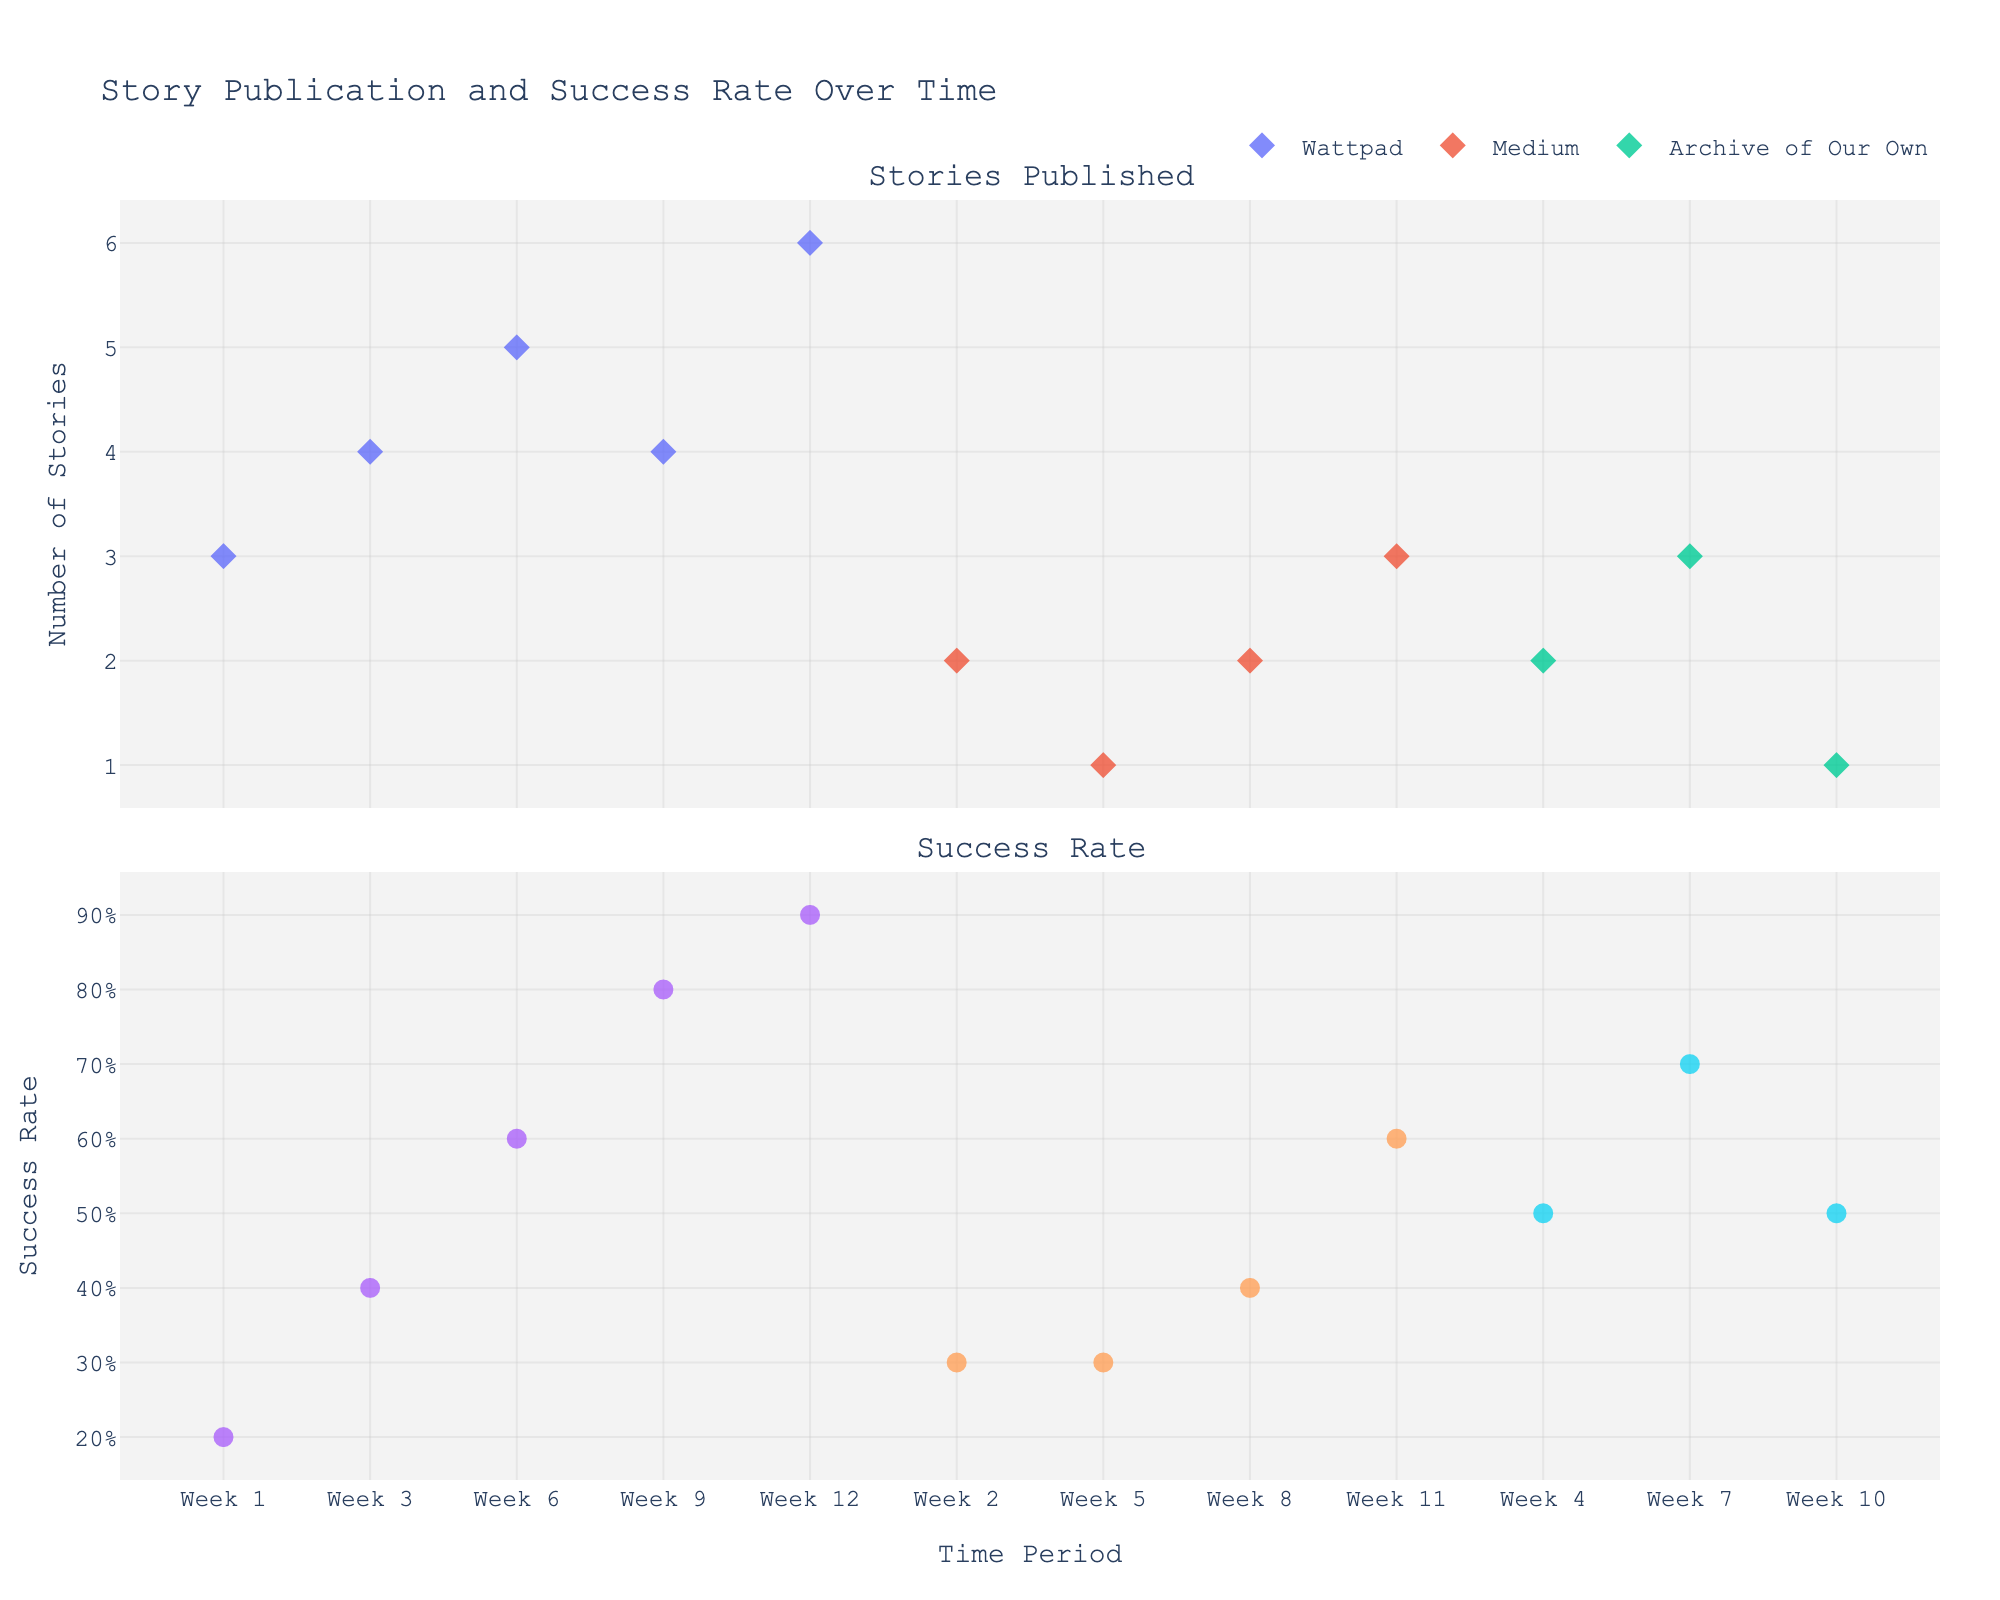What is the title of the figure? The title of the figure can be seen at the very top of the plot.
Answer: Story Publication and Success Rate Over Time Which platform had the highest number of stories published in a single week? To determine this, you can look at the Stories Published subplot and find the platform with the highest data point.
Answer: Wattpad In Week 12, what is the success rate for stories published on Wattpad? Locate Week 12 on the Success Rate subplot and identify the success rate for Wattpad.
Answer: 90% Which platform has the most consistent success rate across the time periods? By observing the Success Rate subplot, determine the platform that shows the least variation in success rate over time.
Answer: Archive of Our Own Between Weeks 4 and 8, which platform exhibited the highest combined success rate? Sum the success rates from Weeks 4 to 8 for each platform and compare between platforms.
Answer: Archive of Our Own How does the trend in stories published on Medium compare with the trend on Wattpad? Compare the markers in the Stories Published subplot for both platforms to see if there's an increasing, decreasing, or flat trend.
Answer: Medium shows a relatively flat trend, while Wattpad shows an increasing trend Did any platform achieve both its peak number of stories published and its peak success rate in the same week? Check both subplots to see if any platform's highest points for stories published and success rate coincide.
Answer: No What is the average success rate for stories published on Archive of Our Own? Add the success rates for Archive of Our Own and divide by the number of weeks it appears in the data.
Answer: 0.57 (57%) Which time period saw the highest total number of stories published across all platforms? Add up the Stories Published for each platform within each week and identify the week with the highest sum.
Answer: Week 12 